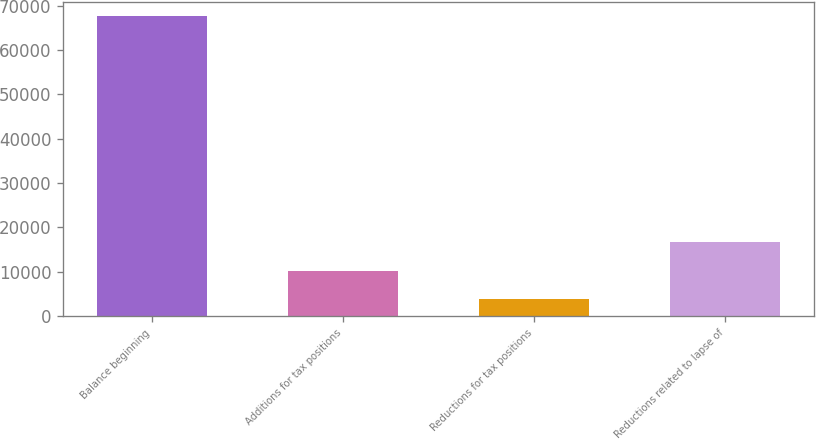Convert chart. <chart><loc_0><loc_0><loc_500><loc_500><bar_chart><fcel>Balance beginning<fcel>Additions for tax positions<fcel>Reductions for tax positions<fcel>Reductions related to lapse of<nl><fcel>67546<fcel>10265.5<fcel>3901<fcel>16630<nl></chart> 